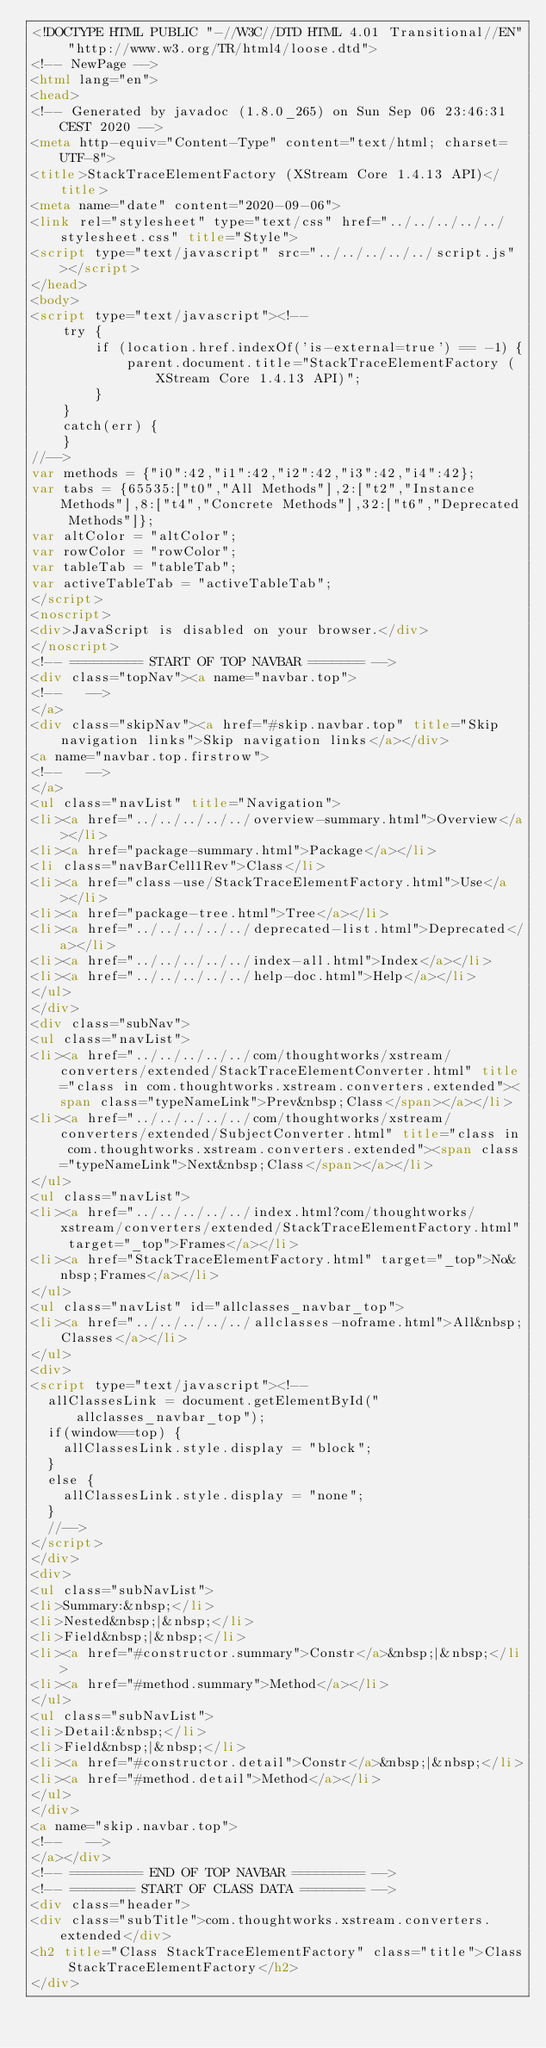Convert code to text. <code><loc_0><loc_0><loc_500><loc_500><_HTML_><!DOCTYPE HTML PUBLIC "-//W3C//DTD HTML 4.01 Transitional//EN" "http://www.w3.org/TR/html4/loose.dtd">
<!-- NewPage -->
<html lang="en">
<head>
<!-- Generated by javadoc (1.8.0_265) on Sun Sep 06 23:46:31 CEST 2020 -->
<meta http-equiv="Content-Type" content="text/html; charset=UTF-8">
<title>StackTraceElementFactory (XStream Core 1.4.13 API)</title>
<meta name="date" content="2020-09-06">
<link rel="stylesheet" type="text/css" href="../../../../../stylesheet.css" title="Style">
<script type="text/javascript" src="../../../../../script.js"></script>
</head>
<body>
<script type="text/javascript"><!--
    try {
        if (location.href.indexOf('is-external=true') == -1) {
            parent.document.title="StackTraceElementFactory (XStream Core 1.4.13 API)";
        }
    }
    catch(err) {
    }
//-->
var methods = {"i0":42,"i1":42,"i2":42,"i3":42,"i4":42};
var tabs = {65535:["t0","All Methods"],2:["t2","Instance Methods"],8:["t4","Concrete Methods"],32:["t6","Deprecated Methods"]};
var altColor = "altColor";
var rowColor = "rowColor";
var tableTab = "tableTab";
var activeTableTab = "activeTableTab";
</script>
<noscript>
<div>JavaScript is disabled on your browser.</div>
</noscript>
<!-- ========= START OF TOP NAVBAR ======= -->
<div class="topNav"><a name="navbar.top">
<!--   -->
</a>
<div class="skipNav"><a href="#skip.navbar.top" title="Skip navigation links">Skip navigation links</a></div>
<a name="navbar.top.firstrow">
<!--   -->
</a>
<ul class="navList" title="Navigation">
<li><a href="../../../../../overview-summary.html">Overview</a></li>
<li><a href="package-summary.html">Package</a></li>
<li class="navBarCell1Rev">Class</li>
<li><a href="class-use/StackTraceElementFactory.html">Use</a></li>
<li><a href="package-tree.html">Tree</a></li>
<li><a href="../../../../../deprecated-list.html">Deprecated</a></li>
<li><a href="../../../../../index-all.html">Index</a></li>
<li><a href="../../../../../help-doc.html">Help</a></li>
</ul>
</div>
<div class="subNav">
<ul class="navList">
<li><a href="../../../../../com/thoughtworks/xstream/converters/extended/StackTraceElementConverter.html" title="class in com.thoughtworks.xstream.converters.extended"><span class="typeNameLink">Prev&nbsp;Class</span></a></li>
<li><a href="../../../../../com/thoughtworks/xstream/converters/extended/SubjectConverter.html" title="class in com.thoughtworks.xstream.converters.extended"><span class="typeNameLink">Next&nbsp;Class</span></a></li>
</ul>
<ul class="navList">
<li><a href="../../../../../index.html?com/thoughtworks/xstream/converters/extended/StackTraceElementFactory.html" target="_top">Frames</a></li>
<li><a href="StackTraceElementFactory.html" target="_top">No&nbsp;Frames</a></li>
</ul>
<ul class="navList" id="allclasses_navbar_top">
<li><a href="../../../../../allclasses-noframe.html">All&nbsp;Classes</a></li>
</ul>
<div>
<script type="text/javascript"><!--
  allClassesLink = document.getElementById("allclasses_navbar_top");
  if(window==top) {
    allClassesLink.style.display = "block";
  }
  else {
    allClassesLink.style.display = "none";
  }
  //-->
</script>
</div>
<div>
<ul class="subNavList">
<li>Summary:&nbsp;</li>
<li>Nested&nbsp;|&nbsp;</li>
<li>Field&nbsp;|&nbsp;</li>
<li><a href="#constructor.summary">Constr</a>&nbsp;|&nbsp;</li>
<li><a href="#method.summary">Method</a></li>
</ul>
<ul class="subNavList">
<li>Detail:&nbsp;</li>
<li>Field&nbsp;|&nbsp;</li>
<li><a href="#constructor.detail">Constr</a>&nbsp;|&nbsp;</li>
<li><a href="#method.detail">Method</a></li>
</ul>
</div>
<a name="skip.navbar.top">
<!--   -->
</a></div>
<!-- ========= END OF TOP NAVBAR ========= -->
<!-- ======== START OF CLASS DATA ======== -->
<div class="header">
<div class="subTitle">com.thoughtworks.xstream.converters.extended</div>
<h2 title="Class StackTraceElementFactory" class="title">Class StackTraceElementFactory</h2>
</div></code> 